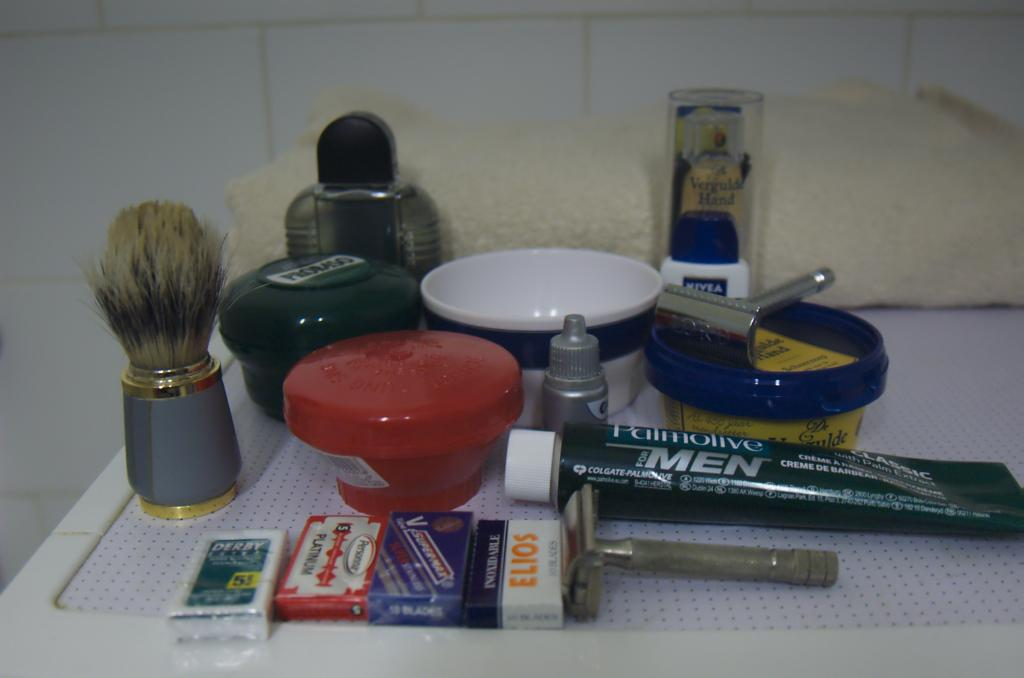<image>
Offer a succinct explanation of the picture presented. A black tube has brand Palmolive and men on the front. 